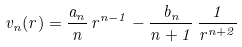Convert formula to latex. <formula><loc_0><loc_0><loc_500><loc_500>v _ { n } ( r ) = \frac { a _ { n } } { n } \, r ^ { n - 1 } - \frac { b _ { n } } { n + 1 } \, \frac { 1 } { r ^ { n + 2 } }</formula> 